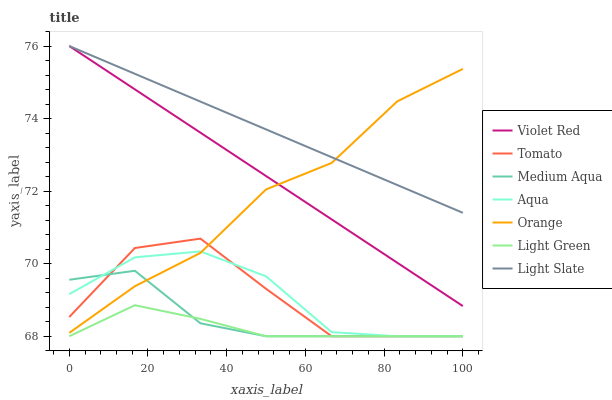Does Light Green have the minimum area under the curve?
Answer yes or no. Yes. Does Light Slate have the maximum area under the curve?
Answer yes or no. Yes. Does Violet Red have the minimum area under the curve?
Answer yes or no. No. Does Violet Red have the maximum area under the curve?
Answer yes or no. No. Is Violet Red the smoothest?
Answer yes or no. Yes. Is Tomato the roughest?
Answer yes or no. Yes. Is Light Slate the smoothest?
Answer yes or no. No. Is Light Slate the roughest?
Answer yes or no. No. Does Tomato have the lowest value?
Answer yes or no. Yes. Does Violet Red have the lowest value?
Answer yes or no. No. Does Light Slate have the highest value?
Answer yes or no. Yes. Does Aqua have the highest value?
Answer yes or no. No. Is Tomato less than Light Slate?
Answer yes or no. Yes. Is Violet Red greater than Medium Aqua?
Answer yes or no. Yes. Does Aqua intersect Medium Aqua?
Answer yes or no. Yes. Is Aqua less than Medium Aqua?
Answer yes or no. No. Is Aqua greater than Medium Aqua?
Answer yes or no. No. Does Tomato intersect Light Slate?
Answer yes or no. No. 